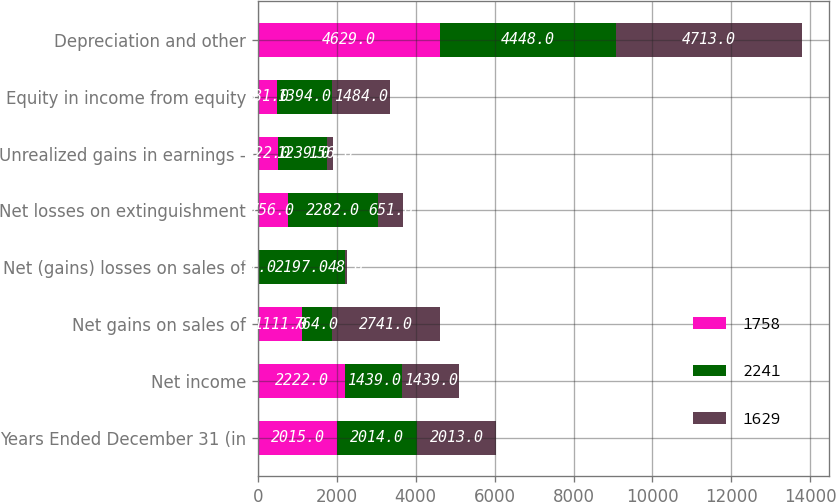Convert chart. <chart><loc_0><loc_0><loc_500><loc_500><stacked_bar_chart><ecel><fcel>Years Ended December 31 (in<fcel>Net income<fcel>Net gains on sales of<fcel>Net (gains) losses on sales of<fcel>Net losses on extinguishment<fcel>Unrealized gains in earnings -<fcel>Equity in income from equity<fcel>Depreciation and other<nl><fcel>1758<fcel>2015<fcel>2222<fcel>1111<fcel>11<fcel>756<fcel>522<fcel>481<fcel>4629<nl><fcel>2241<fcel>2014<fcel>1439<fcel>764<fcel>2197<fcel>2282<fcel>1239<fcel>1394<fcel>4448<nl><fcel>1629<fcel>2013<fcel>1439<fcel>2741<fcel>48<fcel>651<fcel>156<fcel>1484<fcel>4713<nl></chart> 